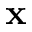<formula> <loc_0><loc_0><loc_500><loc_500>x</formula> 